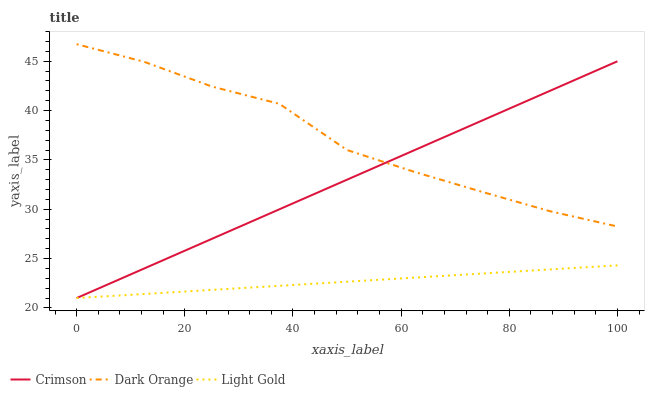Does Light Gold have the minimum area under the curve?
Answer yes or no. Yes. Does Dark Orange have the maximum area under the curve?
Answer yes or no. Yes. Does Dark Orange have the minimum area under the curve?
Answer yes or no. No. Does Light Gold have the maximum area under the curve?
Answer yes or no. No. Is Light Gold the smoothest?
Answer yes or no. Yes. Is Dark Orange the roughest?
Answer yes or no. Yes. Is Dark Orange the smoothest?
Answer yes or no. No. Is Light Gold the roughest?
Answer yes or no. No. Does Crimson have the lowest value?
Answer yes or no. Yes. Does Dark Orange have the lowest value?
Answer yes or no. No. Does Dark Orange have the highest value?
Answer yes or no. Yes. Does Light Gold have the highest value?
Answer yes or no. No. Is Light Gold less than Dark Orange?
Answer yes or no. Yes. Is Dark Orange greater than Light Gold?
Answer yes or no. Yes. Does Dark Orange intersect Crimson?
Answer yes or no. Yes. Is Dark Orange less than Crimson?
Answer yes or no. No. Is Dark Orange greater than Crimson?
Answer yes or no. No. Does Light Gold intersect Dark Orange?
Answer yes or no. No. 